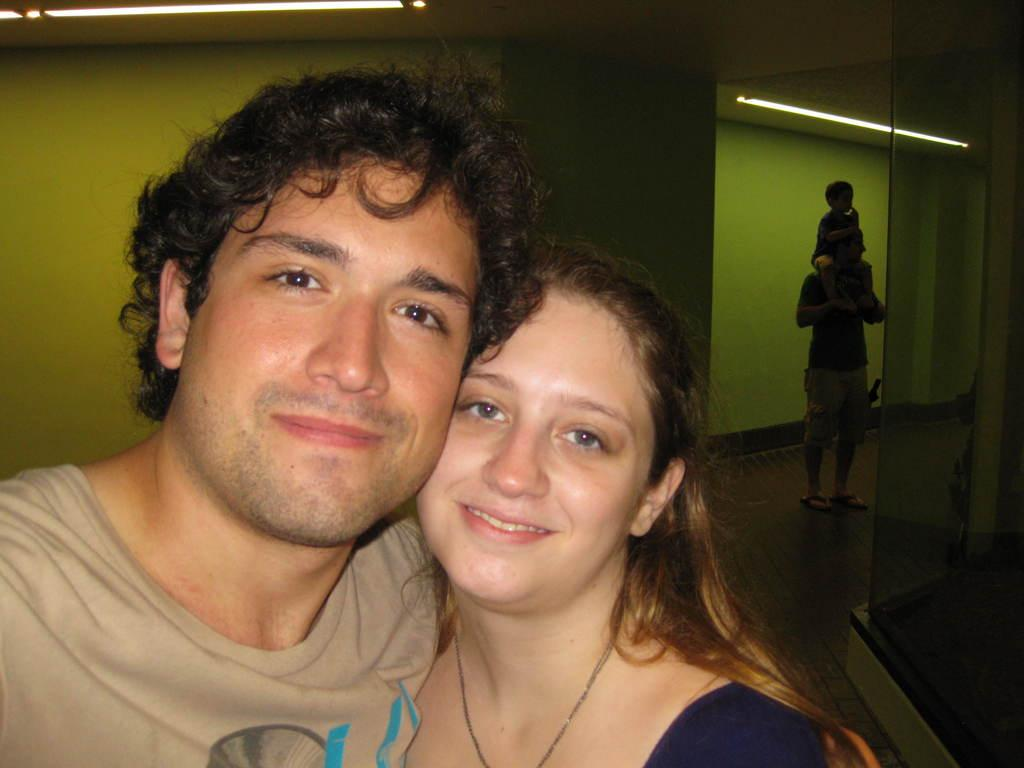How many people are in the image? There is a group of persons standing in the image. Can you describe the activity of one person in the image? There is a person carrying a boy on his shoulders on the right side of the image. What can be seen in the image that provides illumination? There are lights visible in the image. What type of jam is being spread on the trucks in the image? There are no trucks or jam present in the image. How much blood can be seen on the person carrying the boy on his shoulders? There is no blood visible on the person carrying the boy on his shoulders in the image. 